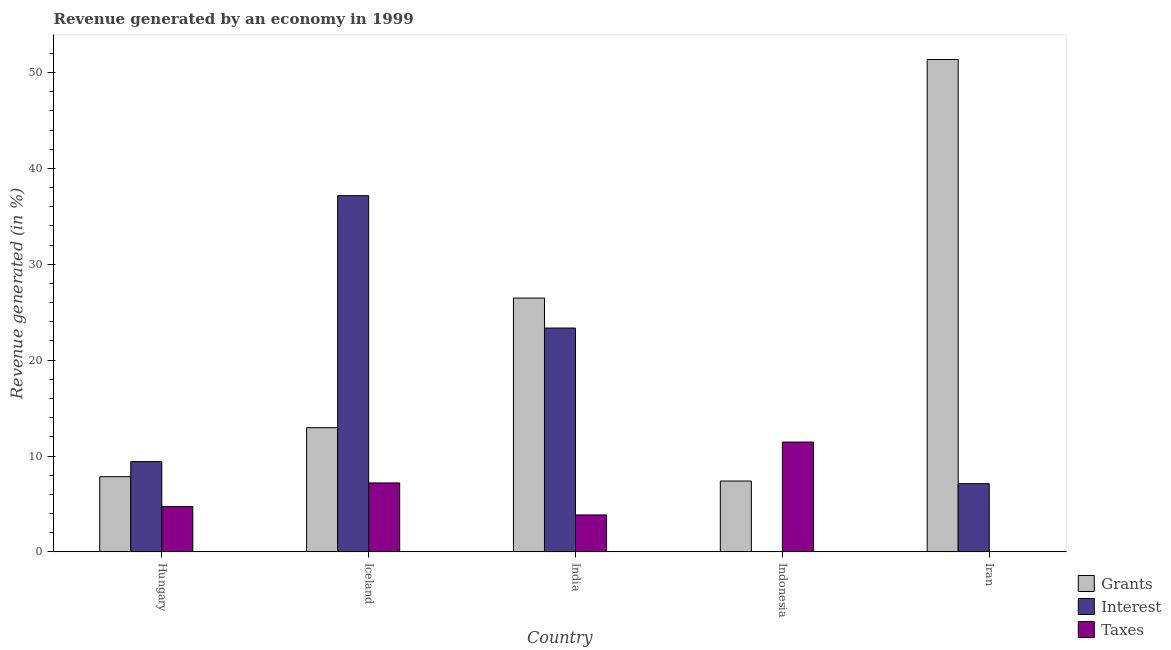How many bars are there on the 3rd tick from the right?
Ensure brevity in your answer.  3. In how many cases, is the number of bars for a given country not equal to the number of legend labels?
Provide a short and direct response. 0. What is the percentage of revenue generated by grants in Iran?
Ensure brevity in your answer.  51.36. Across all countries, what is the maximum percentage of revenue generated by interest?
Offer a terse response. 37.16. Across all countries, what is the minimum percentage of revenue generated by taxes?
Your answer should be compact. 0. In which country was the percentage of revenue generated by grants minimum?
Ensure brevity in your answer.  Indonesia. What is the total percentage of revenue generated by taxes in the graph?
Offer a terse response. 27.23. What is the difference between the percentage of revenue generated by interest in Hungary and that in Iran?
Keep it short and to the point. 2.3. What is the difference between the percentage of revenue generated by taxes in Iran and the percentage of revenue generated by grants in Indonesia?
Provide a succinct answer. -7.39. What is the average percentage of revenue generated by grants per country?
Provide a succinct answer. 21.21. What is the difference between the percentage of revenue generated by grants and percentage of revenue generated by taxes in Iran?
Keep it short and to the point. 51.36. What is the ratio of the percentage of revenue generated by taxes in Indonesia to that in Iran?
Your response must be concise. 9168.87. What is the difference between the highest and the second highest percentage of revenue generated by interest?
Offer a very short reply. 13.81. What is the difference between the highest and the lowest percentage of revenue generated by taxes?
Offer a terse response. 11.45. Is the sum of the percentage of revenue generated by grants in Hungary and Iran greater than the maximum percentage of revenue generated by interest across all countries?
Your answer should be compact. Yes. What does the 2nd bar from the left in India represents?
Your answer should be compact. Interest. What does the 3rd bar from the right in Iceland represents?
Offer a very short reply. Grants. Is it the case that in every country, the sum of the percentage of revenue generated by grants and percentage of revenue generated by interest is greater than the percentage of revenue generated by taxes?
Provide a succinct answer. No. How many bars are there?
Keep it short and to the point. 15. Are all the bars in the graph horizontal?
Make the answer very short. No. Does the graph contain any zero values?
Give a very brief answer. No. Where does the legend appear in the graph?
Your answer should be very brief. Bottom right. How are the legend labels stacked?
Offer a very short reply. Vertical. What is the title of the graph?
Ensure brevity in your answer.  Revenue generated by an economy in 1999. What is the label or title of the Y-axis?
Make the answer very short. Revenue generated (in %). What is the Revenue generated (in %) of Grants in Hungary?
Give a very brief answer. 7.84. What is the Revenue generated (in %) in Interest in Hungary?
Ensure brevity in your answer.  9.42. What is the Revenue generated (in %) in Taxes in Hungary?
Ensure brevity in your answer.  4.73. What is the Revenue generated (in %) in Grants in Iceland?
Make the answer very short. 12.95. What is the Revenue generated (in %) in Interest in Iceland?
Your answer should be very brief. 37.16. What is the Revenue generated (in %) in Taxes in Iceland?
Provide a short and direct response. 7.19. What is the Revenue generated (in %) in Grants in India?
Your answer should be very brief. 26.48. What is the Revenue generated (in %) of Interest in India?
Your answer should be very brief. 23.35. What is the Revenue generated (in %) in Taxes in India?
Offer a very short reply. 3.85. What is the Revenue generated (in %) in Grants in Indonesia?
Your answer should be compact. 7.39. What is the Revenue generated (in %) of Interest in Indonesia?
Give a very brief answer. 5.42987364066156e-5. What is the Revenue generated (in %) in Taxes in Indonesia?
Keep it short and to the point. 11.46. What is the Revenue generated (in %) of Grants in Iran?
Your answer should be very brief. 51.36. What is the Revenue generated (in %) in Interest in Iran?
Provide a short and direct response. 7.11. What is the Revenue generated (in %) in Taxes in Iran?
Your answer should be very brief. 0. Across all countries, what is the maximum Revenue generated (in %) in Grants?
Make the answer very short. 51.36. Across all countries, what is the maximum Revenue generated (in %) in Interest?
Your answer should be compact. 37.16. Across all countries, what is the maximum Revenue generated (in %) of Taxes?
Provide a succinct answer. 11.46. Across all countries, what is the minimum Revenue generated (in %) in Grants?
Keep it short and to the point. 7.39. Across all countries, what is the minimum Revenue generated (in %) of Interest?
Your answer should be very brief. 5.42987364066156e-5. Across all countries, what is the minimum Revenue generated (in %) in Taxes?
Your response must be concise. 0. What is the total Revenue generated (in %) in Grants in the graph?
Your answer should be very brief. 106.03. What is the total Revenue generated (in %) of Interest in the graph?
Give a very brief answer. 77.04. What is the total Revenue generated (in %) of Taxes in the graph?
Ensure brevity in your answer.  27.23. What is the difference between the Revenue generated (in %) of Grants in Hungary and that in Iceland?
Ensure brevity in your answer.  -5.11. What is the difference between the Revenue generated (in %) in Interest in Hungary and that in Iceland?
Your answer should be very brief. -27.74. What is the difference between the Revenue generated (in %) in Taxes in Hungary and that in Iceland?
Your response must be concise. -2.46. What is the difference between the Revenue generated (in %) of Grants in Hungary and that in India?
Keep it short and to the point. -18.63. What is the difference between the Revenue generated (in %) of Interest in Hungary and that in India?
Offer a very short reply. -13.93. What is the difference between the Revenue generated (in %) of Taxes in Hungary and that in India?
Ensure brevity in your answer.  0.88. What is the difference between the Revenue generated (in %) of Grants in Hungary and that in Indonesia?
Provide a succinct answer. 0.45. What is the difference between the Revenue generated (in %) in Interest in Hungary and that in Indonesia?
Your answer should be compact. 9.42. What is the difference between the Revenue generated (in %) in Taxes in Hungary and that in Indonesia?
Keep it short and to the point. -6.73. What is the difference between the Revenue generated (in %) in Grants in Hungary and that in Iran?
Ensure brevity in your answer.  -43.52. What is the difference between the Revenue generated (in %) of Interest in Hungary and that in Iran?
Make the answer very short. 2.3. What is the difference between the Revenue generated (in %) of Taxes in Hungary and that in Iran?
Offer a very short reply. 4.73. What is the difference between the Revenue generated (in %) in Grants in Iceland and that in India?
Provide a short and direct response. -13.52. What is the difference between the Revenue generated (in %) of Interest in Iceland and that in India?
Provide a short and direct response. 13.81. What is the difference between the Revenue generated (in %) in Taxes in Iceland and that in India?
Your answer should be compact. 3.34. What is the difference between the Revenue generated (in %) in Grants in Iceland and that in Indonesia?
Offer a terse response. 5.57. What is the difference between the Revenue generated (in %) in Interest in Iceland and that in Indonesia?
Make the answer very short. 37.16. What is the difference between the Revenue generated (in %) of Taxes in Iceland and that in Indonesia?
Ensure brevity in your answer.  -4.26. What is the difference between the Revenue generated (in %) in Grants in Iceland and that in Iran?
Your answer should be compact. -38.41. What is the difference between the Revenue generated (in %) of Interest in Iceland and that in Iran?
Offer a very short reply. 30.04. What is the difference between the Revenue generated (in %) of Taxes in Iceland and that in Iran?
Your answer should be compact. 7.19. What is the difference between the Revenue generated (in %) in Grants in India and that in Indonesia?
Provide a short and direct response. 19.09. What is the difference between the Revenue generated (in %) of Interest in India and that in Indonesia?
Provide a short and direct response. 23.35. What is the difference between the Revenue generated (in %) of Taxes in India and that in Indonesia?
Give a very brief answer. -7.6. What is the difference between the Revenue generated (in %) of Grants in India and that in Iran?
Make the answer very short. -24.89. What is the difference between the Revenue generated (in %) of Interest in India and that in Iran?
Give a very brief answer. 16.24. What is the difference between the Revenue generated (in %) of Taxes in India and that in Iran?
Offer a terse response. 3.85. What is the difference between the Revenue generated (in %) of Grants in Indonesia and that in Iran?
Provide a succinct answer. -43.97. What is the difference between the Revenue generated (in %) of Interest in Indonesia and that in Iran?
Provide a short and direct response. -7.11. What is the difference between the Revenue generated (in %) in Taxes in Indonesia and that in Iran?
Your answer should be very brief. 11.45. What is the difference between the Revenue generated (in %) in Grants in Hungary and the Revenue generated (in %) in Interest in Iceland?
Provide a succinct answer. -29.31. What is the difference between the Revenue generated (in %) in Grants in Hungary and the Revenue generated (in %) in Taxes in Iceland?
Offer a terse response. 0.65. What is the difference between the Revenue generated (in %) in Interest in Hungary and the Revenue generated (in %) in Taxes in Iceland?
Ensure brevity in your answer.  2.23. What is the difference between the Revenue generated (in %) of Grants in Hungary and the Revenue generated (in %) of Interest in India?
Your answer should be compact. -15.51. What is the difference between the Revenue generated (in %) of Grants in Hungary and the Revenue generated (in %) of Taxes in India?
Provide a succinct answer. 3.99. What is the difference between the Revenue generated (in %) of Interest in Hungary and the Revenue generated (in %) of Taxes in India?
Provide a short and direct response. 5.57. What is the difference between the Revenue generated (in %) in Grants in Hungary and the Revenue generated (in %) in Interest in Indonesia?
Keep it short and to the point. 7.84. What is the difference between the Revenue generated (in %) in Grants in Hungary and the Revenue generated (in %) in Taxes in Indonesia?
Ensure brevity in your answer.  -3.61. What is the difference between the Revenue generated (in %) of Interest in Hungary and the Revenue generated (in %) of Taxes in Indonesia?
Give a very brief answer. -2.04. What is the difference between the Revenue generated (in %) of Grants in Hungary and the Revenue generated (in %) of Interest in Iran?
Provide a succinct answer. 0.73. What is the difference between the Revenue generated (in %) in Grants in Hungary and the Revenue generated (in %) in Taxes in Iran?
Your response must be concise. 7.84. What is the difference between the Revenue generated (in %) of Interest in Hungary and the Revenue generated (in %) of Taxes in Iran?
Offer a very short reply. 9.42. What is the difference between the Revenue generated (in %) of Grants in Iceland and the Revenue generated (in %) of Interest in India?
Make the answer very short. -10.4. What is the difference between the Revenue generated (in %) in Grants in Iceland and the Revenue generated (in %) in Taxes in India?
Give a very brief answer. 9.1. What is the difference between the Revenue generated (in %) of Interest in Iceland and the Revenue generated (in %) of Taxes in India?
Provide a succinct answer. 33.31. What is the difference between the Revenue generated (in %) in Grants in Iceland and the Revenue generated (in %) in Interest in Indonesia?
Offer a very short reply. 12.95. What is the difference between the Revenue generated (in %) in Grants in Iceland and the Revenue generated (in %) in Taxes in Indonesia?
Offer a terse response. 1.5. What is the difference between the Revenue generated (in %) of Interest in Iceland and the Revenue generated (in %) of Taxes in Indonesia?
Offer a very short reply. 25.7. What is the difference between the Revenue generated (in %) in Grants in Iceland and the Revenue generated (in %) in Interest in Iran?
Keep it short and to the point. 5.84. What is the difference between the Revenue generated (in %) in Grants in Iceland and the Revenue generated (in %) in Taxes in Iran?
Provide a short and direct response. 12.95. What is the difference between the Revenue generated (in %) of Interest in Iceland and the Revenue generated (in %) of Taxes in Iran?
Make the answer very short. 37.16. What is the difference between the Revenue generated (in %) of Grants in India and the Revenue generated (in %) of Interest in Indonesia?
Ensure brevity in your answer.  26.48. What is the difference between the Revenue generated (in %) of Grants in India and the Revenue generated (in %) of Taxes in Indonesia?
Offer a very short reply. 15.02. What is the difference between the Revenue generated (in %) in Interest in India and the Revenue generated (in %) in Taxes in Indonesia?
Your answer should be very brief. 11.9. What is the difference between the Revenue generated (in %) in Grants in India and the Revenue generated (in %) in Interest in Iran?
Give a very brief answer. 19.36. What is the difference between the Revenue generated (in %) of Grants in India and the Revenue generated (in %) of Taxes in Iran?
Your answer should be compact. 26.48. What is the difference between the Revenue generated (in %) in Interest in India and the Revenue generated (in %) in Taxes in Iran?
Provide a short and direct response. 23.35. What is the difference between the Revenue generated (in %) in Grants in Indonesia and the Revenue generated (in %) in Interest in Iran?
Your response must be concise. 0.28. What is the difference between the Revenue generated (in %) in Grants in Indonesia and the Revenue generated (in %) in Taxes in Iran?
Offer a very short reply. 7.39. What is the difference between the Revenue generated (in %) of Interest in Indonesia and the Revenue generated (in %) of Taxes in Iran?
Offer a terse response. -0. What is the average Revenue generated (in %) of Grants per country?
Make the answer very short. 21.21. What is the average Revenue generated (in %) in Interest per country?
Make the answer very short. 15.41. What is the average Revenue generated (in %) in Taxes per country?
Keep it short and to the point. 5.45. What is the difference between the Revenue generated (in %) in Grants and Revenue generated (in %) in Interest in Hungary?
Ensure brevity in your answer.  -1.57. What is the difference between the Revenue generated (in %) of Grants and Revenue generated (in %) of Taxes in Hungary?
Keep it short and to the point. 3.12. What is the difference between the Revenue generated (in %) in Interest and Revenue generated (in %) in Taxes in Hungary?
Provide a short and direct response. 4.69. What is the difference between the Revenue generated (in %) in Grants and Revenue generated (in %) in Interest in Iceland?
Ensure brevity in your answer.  -24.2. What is the difference between the Revenue generated (in %) of Grants and Revenue generated (in %) of Taxes in Iceland?
Ensure brevity in your answer.  5.76. What is the difference between the Revenue generated (in %) in Interest and Revenue generated (in %) in Taxes in Iceland?
Provide a short and direct response. 29.97. What is the difference between the Revenue generated (in %) in Grants and Revenue generated (in %) in Interest in India?
Keep it short and to the point. 3.13. What is the difference between the Revenue generated (in %) of Grants and Revenue generated (in %) of Taxes in India?
Offer a very short reply. 22.62. What is the difference between the Revenue generated (in %) in Interest and Revenue generated (in %) in Taxes in India?
Provide a succinct answer. 19.5. What is the difference between the Revenue generated (in %) in Grants and Revenue generated (in %) in Interest in Indonesia?
Your answer should be very brief. 7.39. What is the difference between the Revenue generated (in %) in Grants and Revenue generated (in %) in Taxes in Indonesia?
Your response must be concise. -4.07. What is the difference between the Revenue generated (in %) of Interest and Revenue generated (in %) of Taxes in Indonesia?
Provide a short and direct response. -11.46. What is the difference between the Revenue generated (in %) in Grants and Revenue generated (in %) in Interest in Iran?
Provide a short and direct response. 44.25. What is the difference between the Revenue generated (in %) of Grants and Revenue generated (in %) of Taxes in Iran?
Your answer should be compact. 51.36. What is the difference between the Revenue generated (in %) of Interest and Revenue generated (in %) of Taxes in Iran?
Your answer should be compact. 7.11. What is the ratio of the Revenue generated (in %) of Grants in Hungary to that in Iceland?
Make the answer very short. 0.61. What is the ratio of the Revenue generated (in %) in Interest in Hungary to that in Iceland?
Ensure brevity in your answer.  0.25. What is the ratio of the Revenue generated (in %) in Taxes in Hungary to that in Iceland?
Your answer should be compact. 0.66. What is the ratio of the Revenue generated (in %) of Grants in Hungary to that in India?
Offer a very short reply. 0.3. What is the ratio of the Revenue generated (in %) of Interest in Hungary to that in India?
Give a very brief answer. 0.4. What is the ratio of the Revenue generated (in %) in Taxes in Hungary to that in India?
Offer a terse response. 1.23. What is the ratio of the Revenue generated (in %) of Grants in Hungary to that in Indonesia?
Make the answer very short. 1.06. What is the ratio of the Revenue generated (in %) of Interest in Hungary to that in Indonesia?
Keep it short and to the point. 1.73e+05. What is the ratio of the Revenue generated (in %) of Taxes in Hungary to that in Indonesia?
Offer a terse response. 0.41. What is the ratio of the Revenue generated (in %) in Grants in Hungary to that in Iran?
Make the answer very short. 0.15. What is the ratio of the Revenue generated (in %) of Interest in Hungary to that in Iran?
Your answer should be compact. 1.32. What is the ratio of the Revenue generated (in %) of Taxes in Hungary to that in Iran?
Your answer should be compact. 3784.66. What is the ratio of the Revenue generated (in %) in Grants in Iceland to that in India?
Offer a terse response. 0.49. What is the ratio of the Revenue generated (in %) in Interest in Iceland to that in India?
Offer a terse response. 1.59. What is the ratio of the Revenue generated (in %) of Taxes in Iceland to that in India?
Ensure brevity in your answer.  1.87. What is the ratio of the Revenue generated (in %) of Grants in Iceland to that in Indonesia?
Your response must be concise. 1.75. What is the ratio of the Revenue generated (in %) of Interest in Iceland to that in Indonesia?
Provide a succinct answer. 6.84e+05. What is the ratio of the Revenue generated (in %) of Taxes in Iceland to that in Indonesia?
Your response must be concise. 0.63. What is the ratio of the Revenue generated (in %) of Grants in Iceland to that in Iran?
Give a very brief answer. 0.25. What is the ratio of the Revenue generated (in %) of Interest in Iceland to that in Iran?
Your answer should be very brief. 5.22. What is the ratio of the Revenue generated (in %) in Taxes in Iceland to that in Iran?
Provide a succinct answer. 5756.41. What is the ratio of the Revenue generated (in %) in Grants in India to that in Indonesia?
Make the answer very short. 3.58. What is the ratio of the Revenue generated (in %) of Interest in India to that in Indonesia?
Provide a short and direct response. 4.30e+05. What is the ratio of the Revenue generated (in %) in Taxes in India to that in Indonesia?
Offer a very short reply. 0.34. What is the ratio of the Revenue generated (in %) in Grants in India to that in Iran?
Your answer should be compact. 0.52. What is the ratio of the Revenue generated (in %) in Interest in India to that in Iran?
Your response must be concise. 3.28. What is the ratio of the Revenue generated (in %) in Taxes in India to that in Iran?
Give a very brief answer. 3083.41. What is the ratio of the Revenue generated (in %) of Grants in Indonesia to that in Iran?
Give a very brief answer. 0.14. What is the ratio of the Revenue generated (in %) of Interest in Indonesia to that in Iran?
Keep it short and to the point. 0. What is the ratio of the Revenue generated (in %) of Taxes in Indonesia to that in Iran?
Your answer should be compact. 9168.87. What is the difference between the highest and the second highest Revenue generated (in %) in Grants?
Your response must be concise. 24.89. What is the difference between the highest and the second highest Revenue generated (in %) of Interest?
Your response must be concise. 13.81. What is the difference between the highest and the second highest Revenue generated (in %) of Taxes?
Keep it short and to the point. 4.26. What is the difference between the highest and the lowest Revenue generated (in %) of Grants?
Your answer should be compact. 43.97. What is the difference between the highest and the lowest Revenue generated (in %) in Interest?
Ensure brevity in your answer.  37.16. What is the difference between the highest and the lowest Revenue generated (in %) in Taxes?
Make the answer very short. 11.45. 